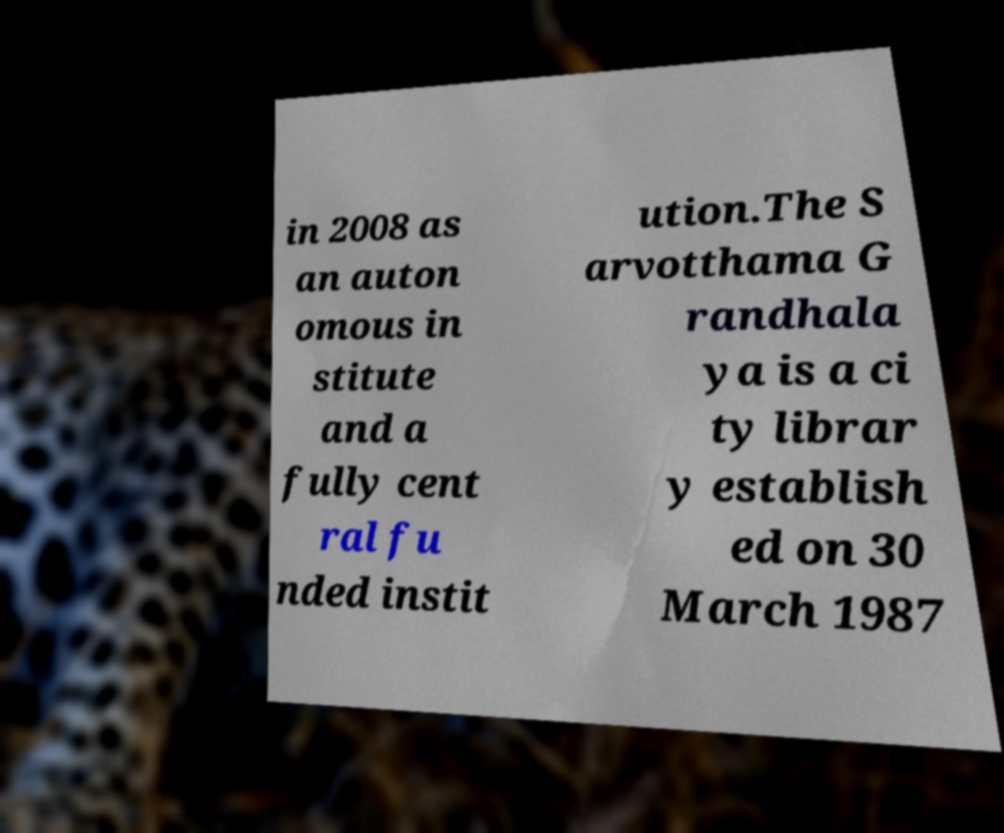What messages or text are displayed in this image? I need them in a readable, typed format. in 2008 as an auton omous in stitute and a fully cent ral fu nded instit ution.The S arvotthama G randhala ya is a ci ty librar y establish ed on 30 March 1987 